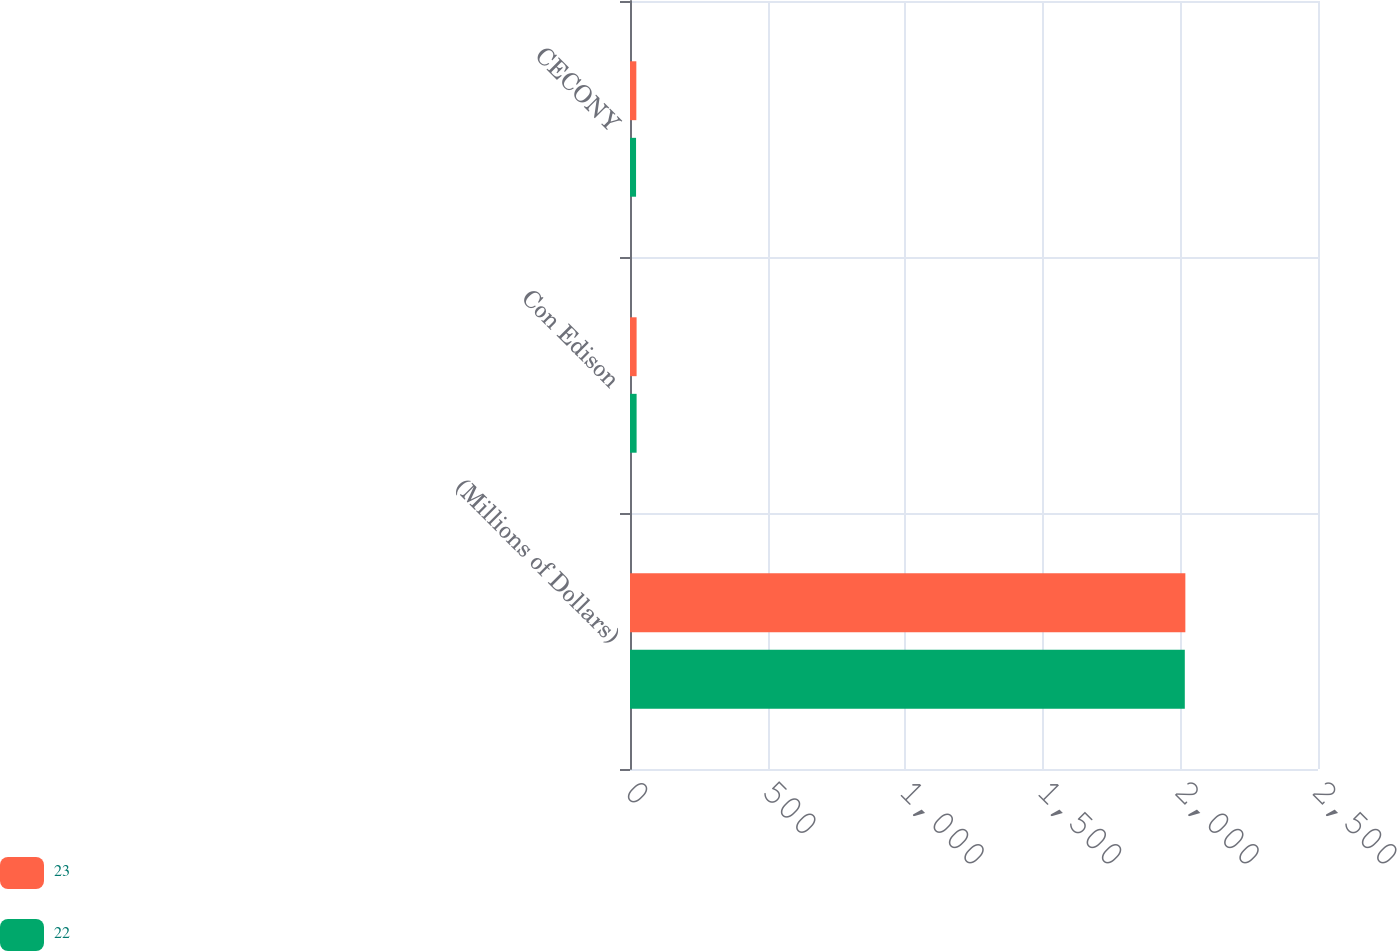<chart> <loc_0><loc_0><loc_500><loc_500><stacked_bar_chart><ecel><fcel>(Millions of Dollars)<fcel>Con Edison<fcel>CECONY<nl><fcel>23<fcel>2018<fcel>24<fcel>23<nl><fcel>22<fcel>2016<fcel>24<fcel>22<nl></chart> 